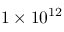<formula> <loc_0><loc_0><loc_500><loc_500>1 \times 1 0 ^ { 1 2 }</formula> 